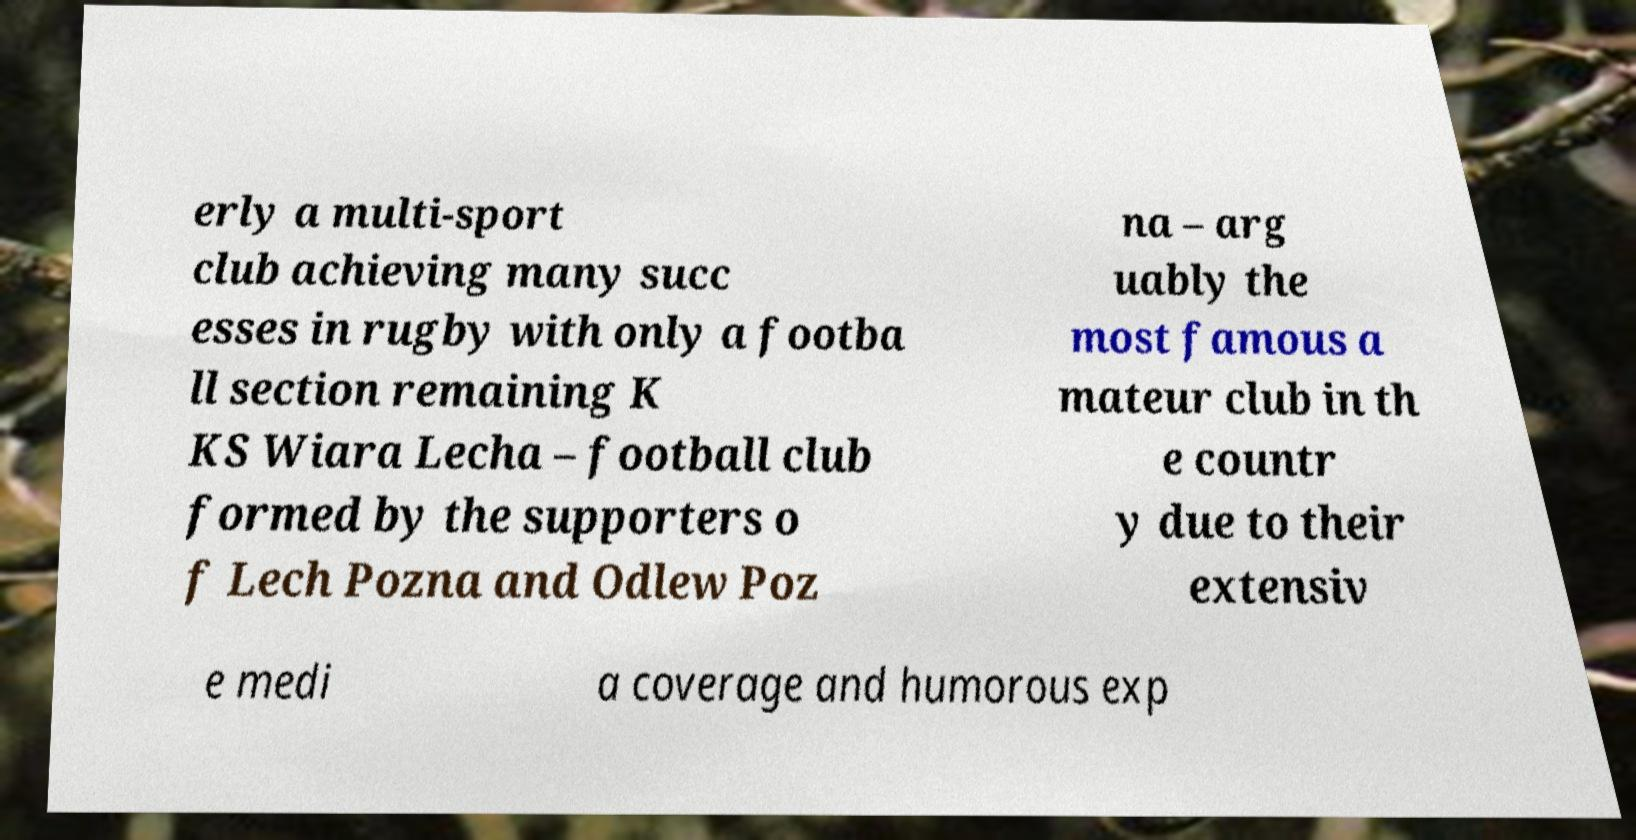Could you extract and type out the text from this image? erly a multi-sport club achieving many succ esses in rugby with only a footba ll section remaining K KS Wiara Lecha – football club formed by the supporters o f Lech Pozna and Odlew Poz na – arg uably the most famous a mateur club in th e countr y due to their extensiv e medi a coverage and humorous exp 